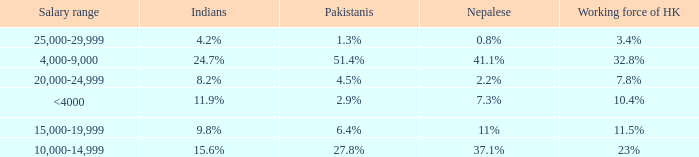If the salary range is 4,000-9,000, what is the Indians %? 24.7%. 